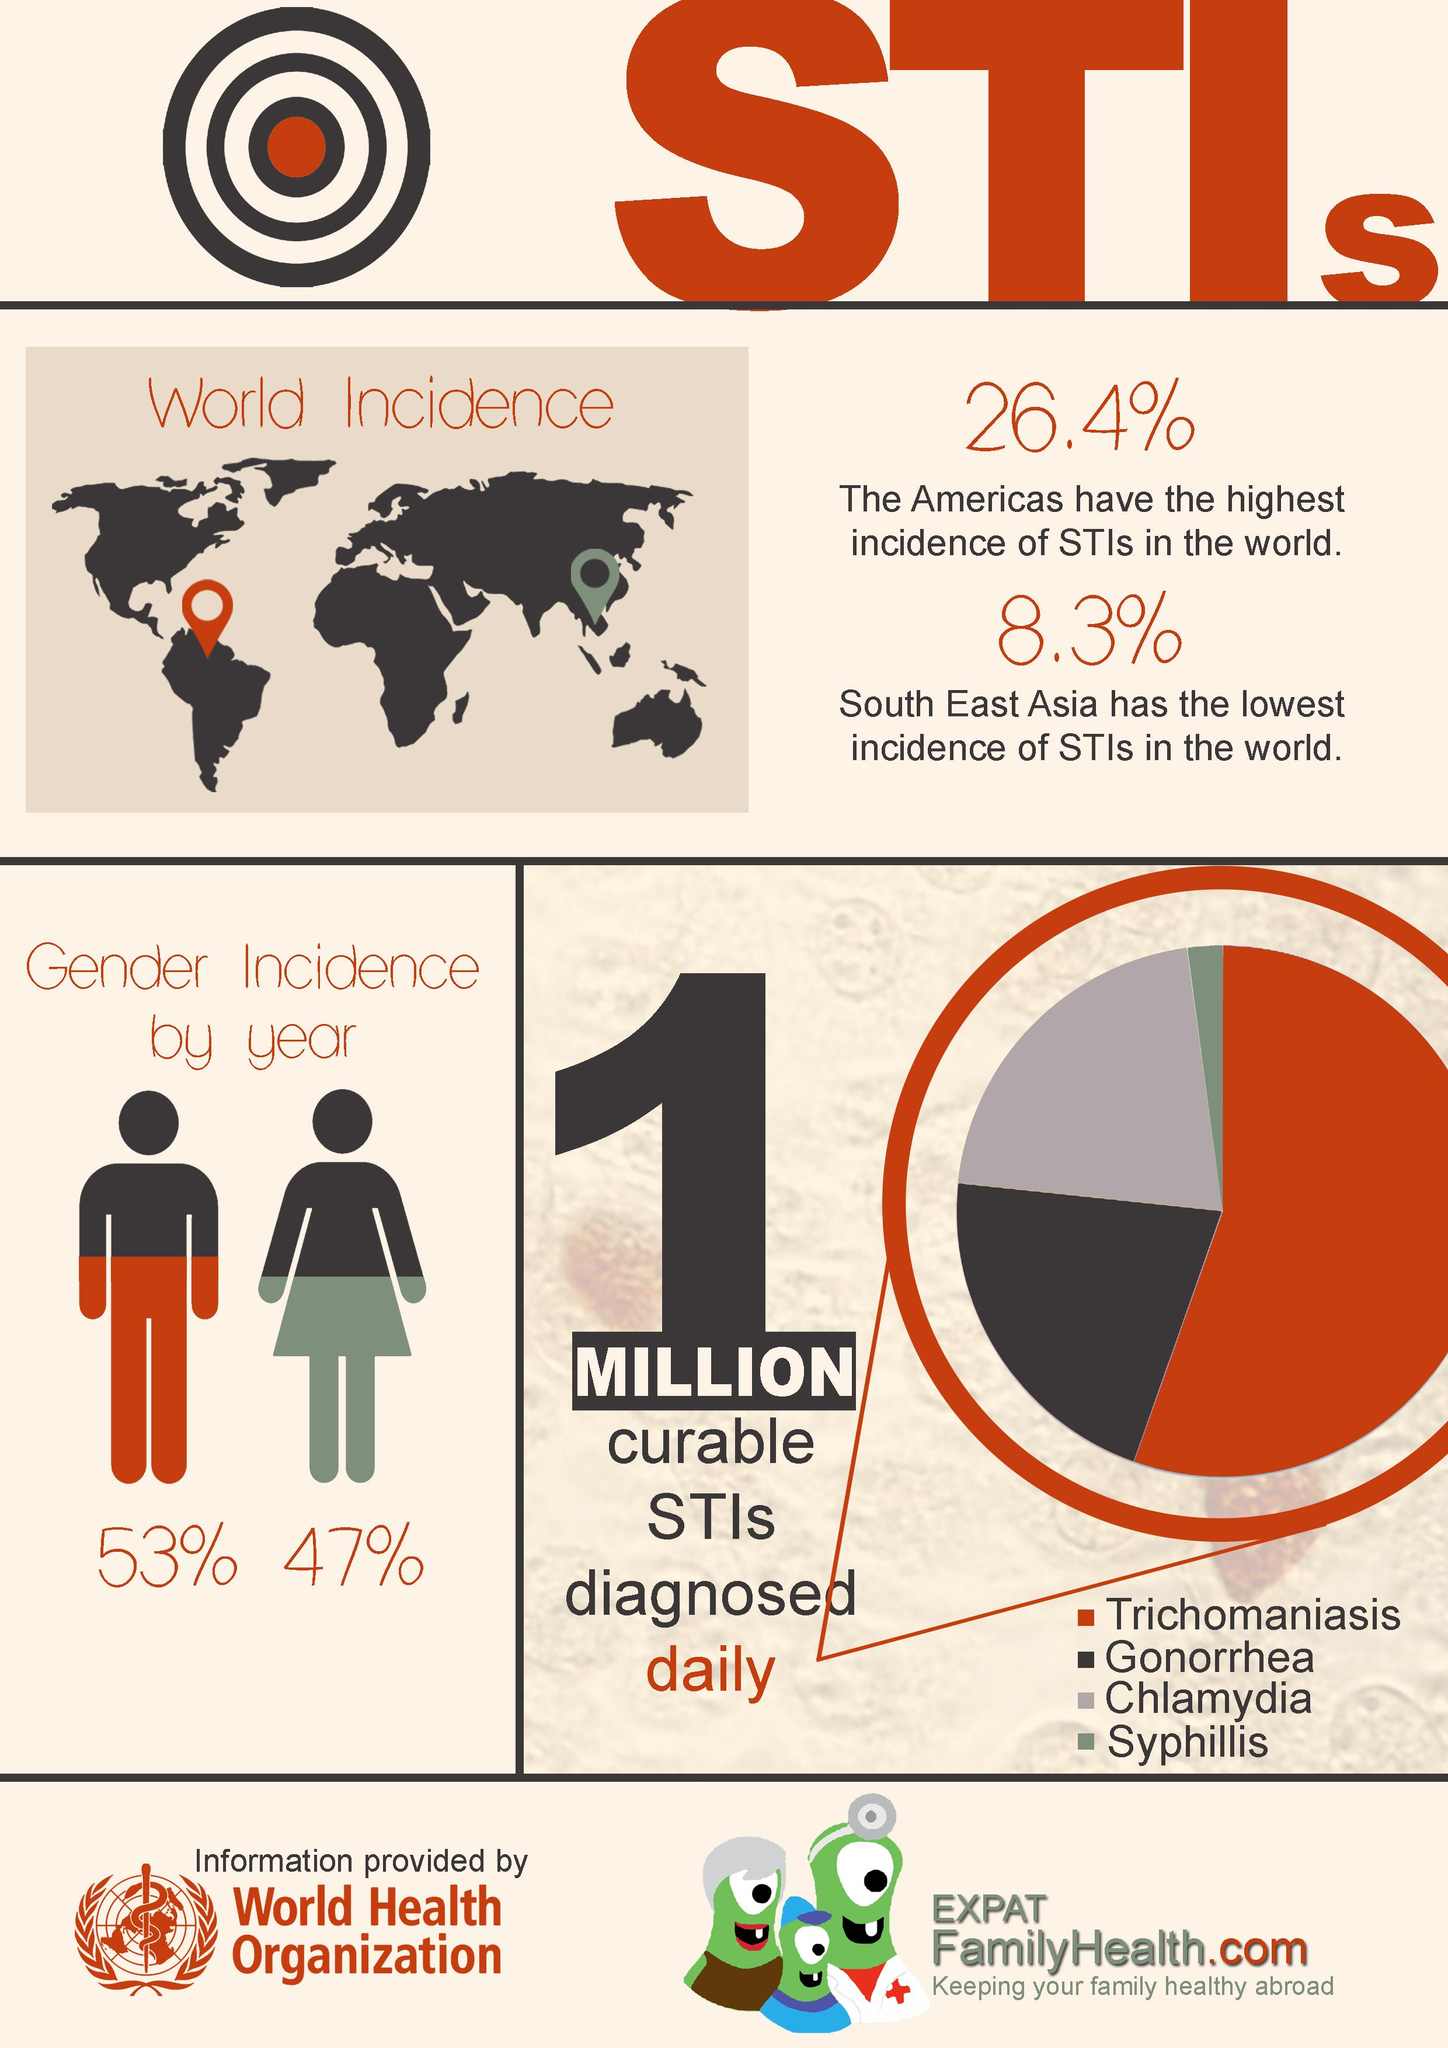Point out several critical features in this image. The graph shows that the top three STIs are Trichomoniasis, Gonorrhea, and Chlamydia. It has been found that men have a higher incidence of STIs compared to women. The rate of sexually transmitted infections (STIs) in women is lower than in men by 6%. The rate of incidence of STIs in the Americas is 18.1% while it is 18.1% in South East Asia. The second most commonly diagnosed STI is gonorrhea. 